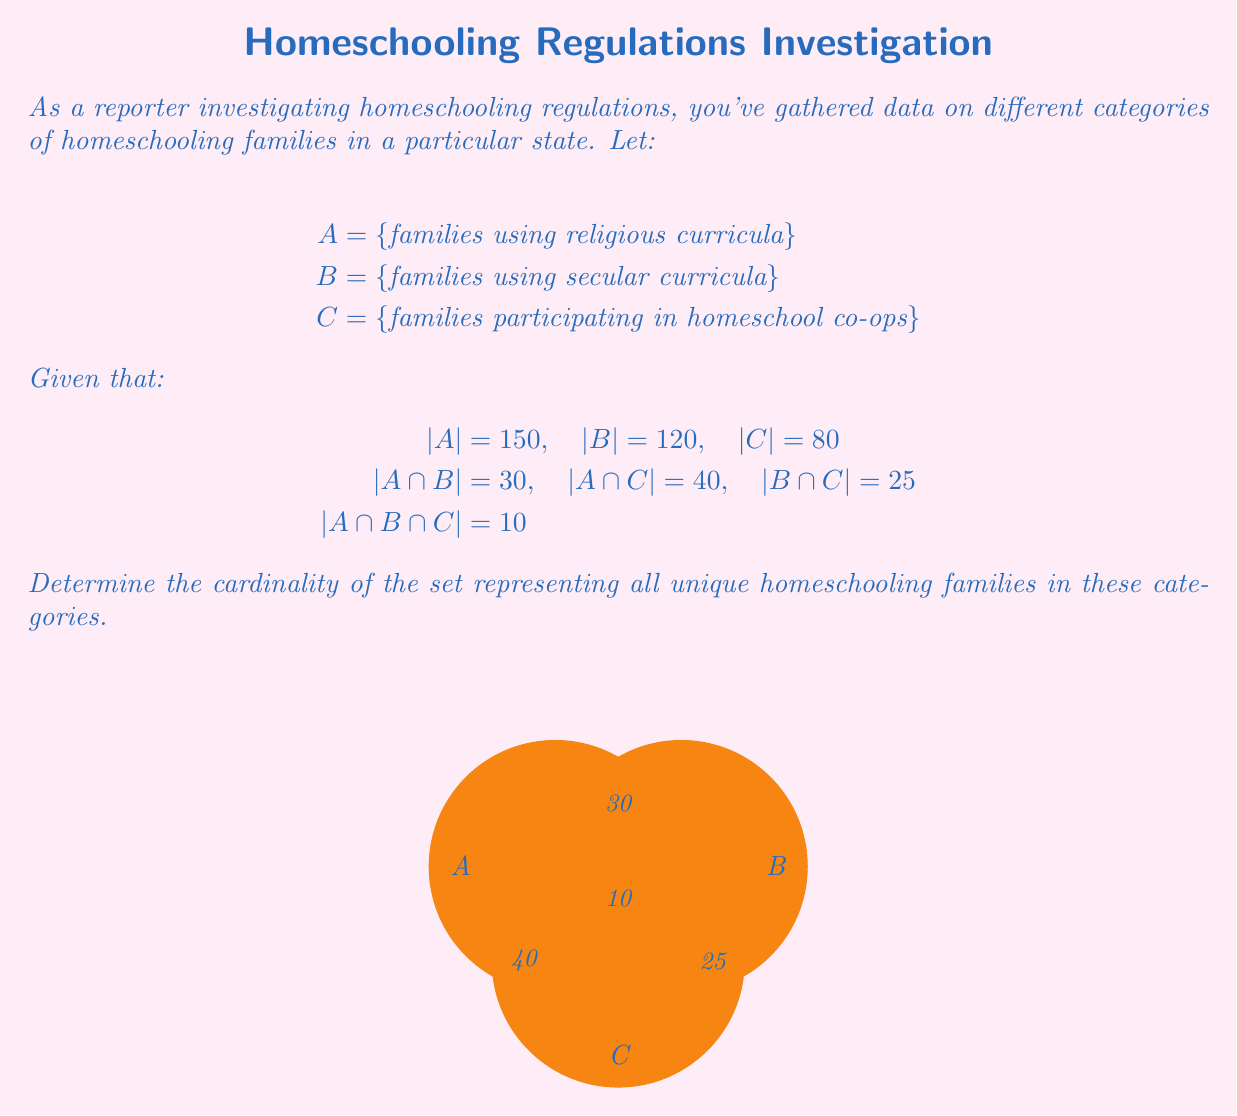Give your solution to this math problem. To solve this problem, we'll use the Inclusion-Exclusion Principle for three sets:

1) First, let's recall the formula:
   $$|A \cup B \cup C| = |A| + |B| + |C| - |A \cap B| - |A \cap C| - |B \cap C| + |A \cap B \cap C|$$

2) Now, let's substitute the given values:
   $$|A \cup B \cup C| = 150 + 120 + 80 - 30 - 40 - 25 + 10$$

3) Let's calculate step by step:
   $$|A \cup B \cup C| = 350 - 95 + 10$$
   $$|A \cup B \cup C| = 255 + 10$$
   $$|A \cup B \cup C| = 265$$

4) Therefore, the cardinality of the set representing all unique homeschooling families in these categories is 265.

This means there are 265 distinct families across all three categories, accounting for overlaps between the categories.
Answer: 265 